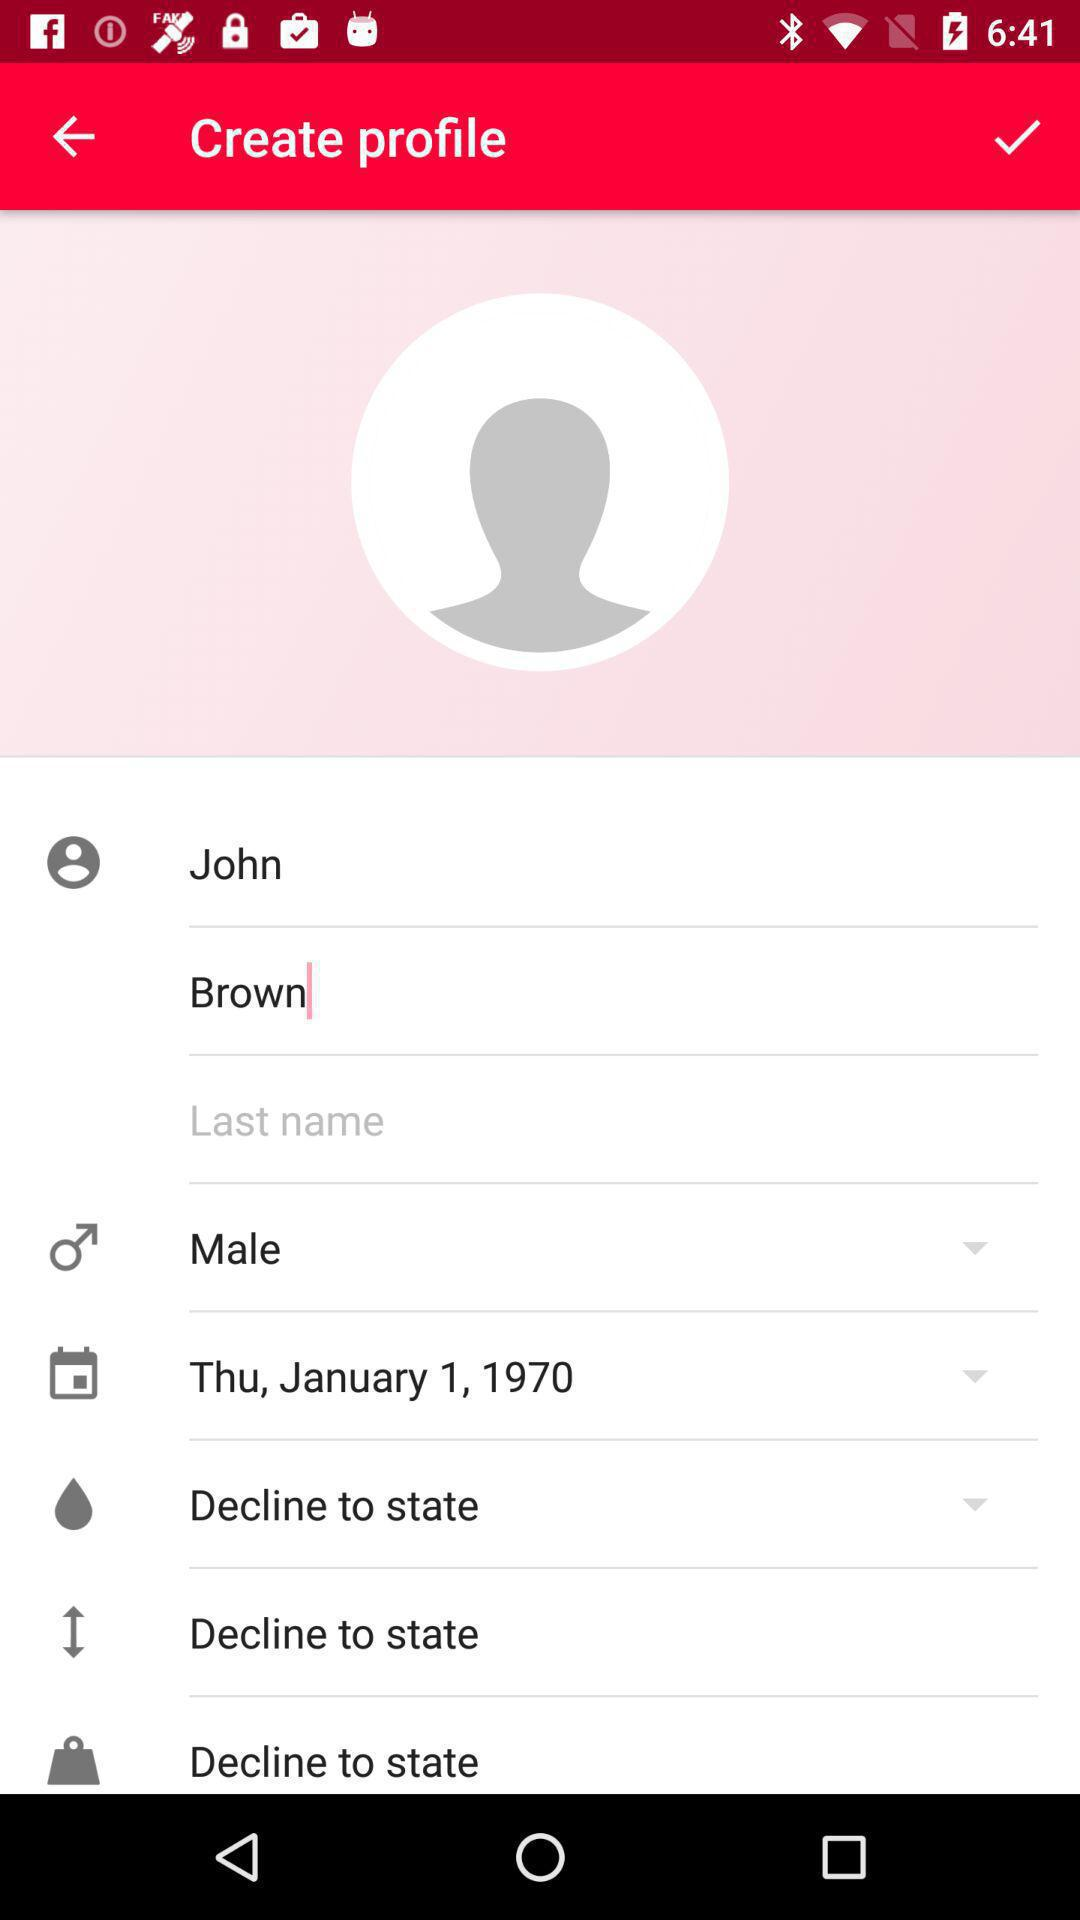What is the user name? The user name is John Brown. 